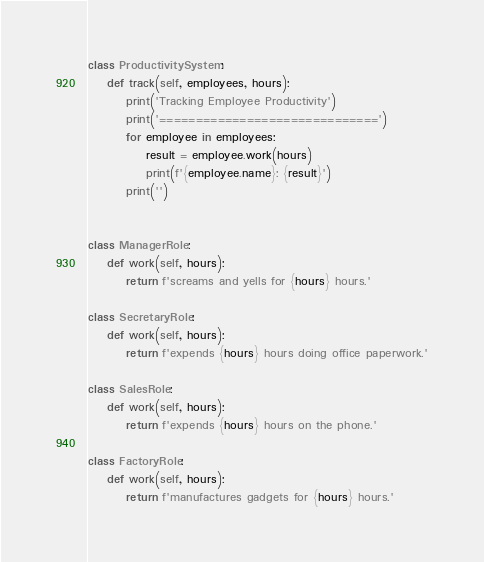<code> <loc_0><loc_0><loc_500><loc_500><_Python_>class ProductivitySystem:
    def track(self, employees, hours):
        print('Tracking Employee Productivity')
        print('==============================')
        for employee in employees:
            result = employee.work(hours)
            print(f'{employee.name}: {result}')
        print('')


class ManagerRole:
    def work(self, hours):
        return f'screams and yells for {hours} hours.'

class SecretaryRole:
    def work(self, hours):
        return f'expends {hours} hours doing office paperwork.'

class SalesRole:
    def work(self, hours):
        return f'expends {hours} hours on the phone.'

class FactoryRole:
    def work(self, hours):
        return f'manufactures gadgets for {hours} hours.'
</code> 